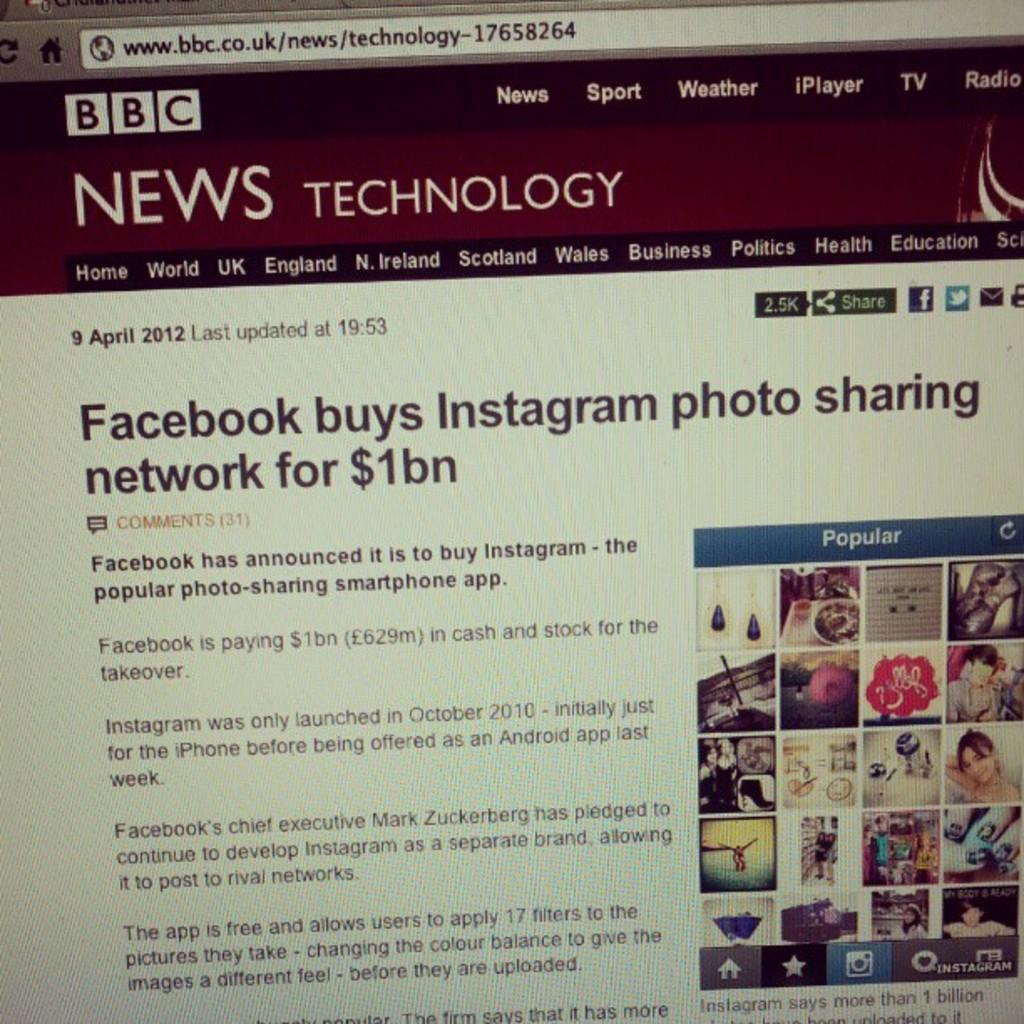<image>
Create a compact narrative representing the image presented. A BBC News story about Facebook buying Instagram for $1bn. 